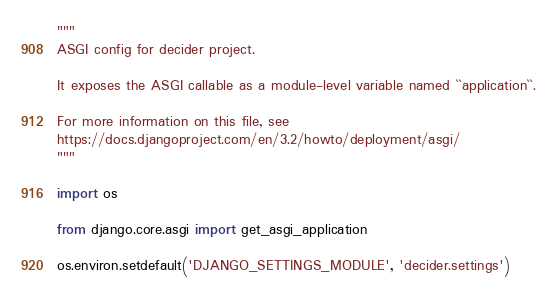Convert code to text. <code><loc_0><loc_0><loc_500><loc_500><_Python_>"""
ASGI config for decider project.

It exposes the ASGI callable as a module-level variable named ``application``.

For more information on this file, see
https://docs.djangoproject.com/en/3.2/howto/deployment/asgi/
"""

import os

from django.core.asgi import get_asgi_application

os.environ.setdefault('DJANGO_SETTINGS_MODULE', 'decider.settings')
</code> 